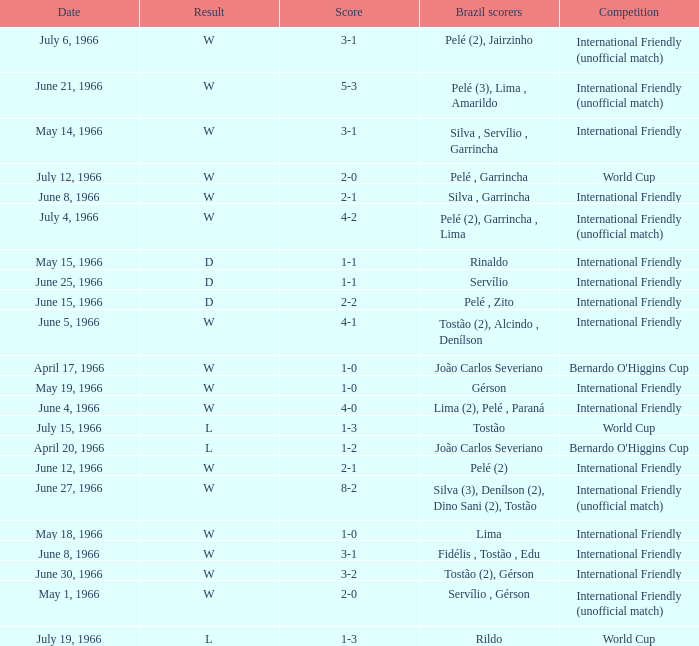What is the result when the score is 4-0? W. 